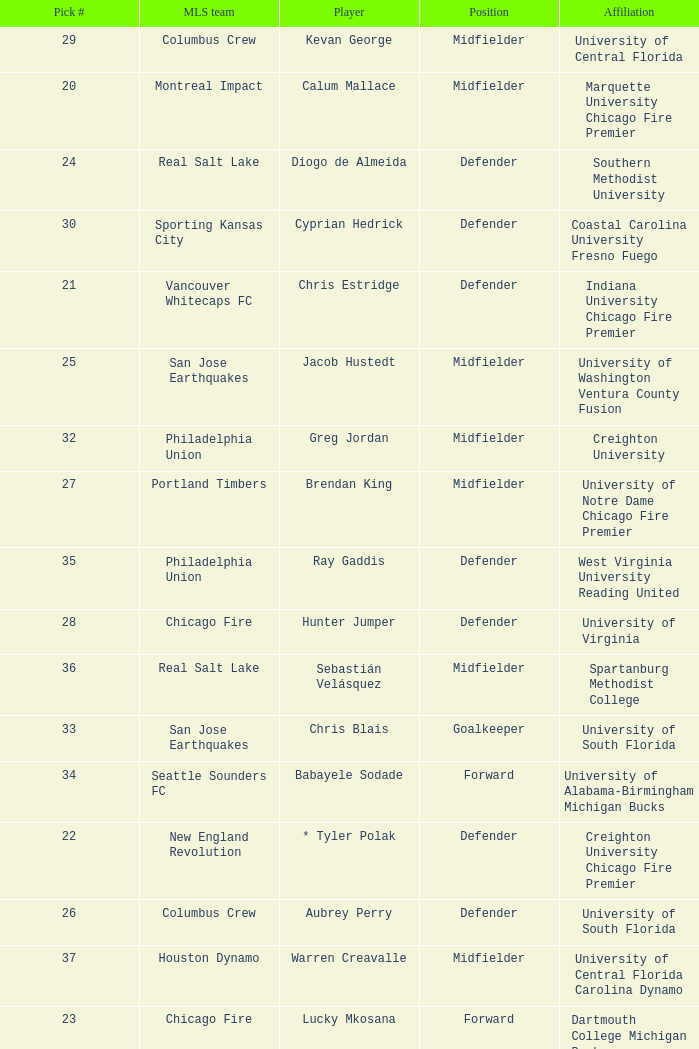What university was Kevan George affiliated with? University of Central Florida. 